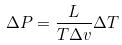Convert formula to latex. <formula><loc_0><loc_0><loc_500><loc_500>\Delta P = \frac { L } { T \Delta v } \Delta T</formula> 